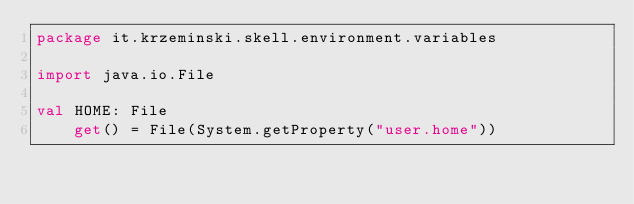<code> <loc_0><loc_0><loc_500><loc_500><_Kotlin_>package it.krzeminski.skell.environment.variables

import java.io.File

val HOME: File
    get() = File(System.getProperty("user.home"))
</code> 